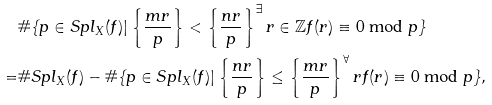<formula> <loc_0><loc_0><loc_500><loc_500>& \# \{ p \in S p l _ { X } ( f ) | \left \{ \frac { m r } { p } \right \} < \left \{ \frac { n r } { p } \right \} ^ { \exists } r \in \mathbb { Z } f ( r ) \equiv 0 \bmod p \} \\ = & \# S p l _ { X } ( f ) - \# \{ p \in S p l _ { X } ( f ) | \left \{ \frac { n r } { p } \right \} \leq \left \{ \frac { m r } { p } \right \} ^ { \forall } r f ( r ) \equiv 0 \bmod p \} ,</formula> 